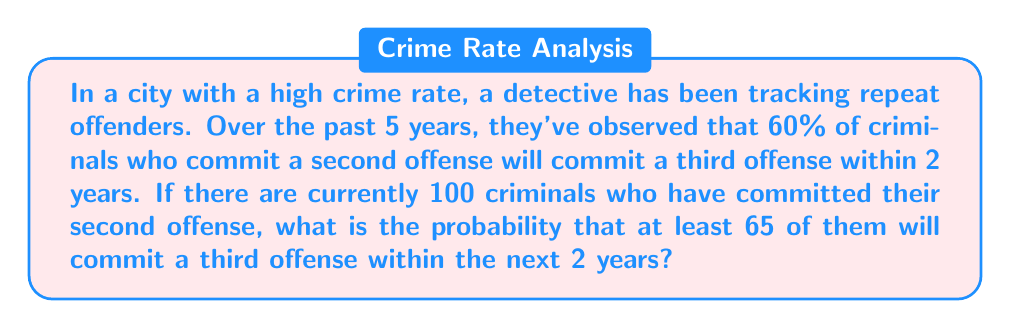Solve this math problem. To solve this problem, we need to use the binomial probability distribution and then calculate the cumulative probability.

Step 1: Identify the parameters
n = 100 (number of criminals)
p = 0.60 (probability of committing a third offense)
q = 1 - p = 0.40 (probability of not committing a third offense)
X = number of criminals committing a third offense
We want P(X ≥ 65)

Step 2: Calculate P(X ≥ 65) using the complement event
P(X ≥ 65) = 1 - P(X < 65) = 1 - P(X ≤ 64)

Step 3: Use the cumulative binomial probability formula
$$P(X \leq k) = \sum_{i=0}^k \binom{n}{i} p^i q^{n-i}$$

In this case:
$$P(X \geq 65) = 1 - \sum_{i=0}^{64} \binom{100}{i} (0.60)^i (0.40)^{100-i}$$

Step 4: Use a calculator or statistical software to compute this value
The result of this calculation is approximately 0.8238.

Therefore, the probability that at least 65 out of 100 criminals will commit a third offense within 2 years is about 0.8238 or 82.38%.
Answer: 0.8238 